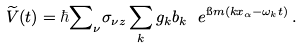<formula> <loc_0><loc_0><loc_500><loc_500>\widetilde { V } ( t ) = \hbar { \sum } _ { \nu } \sigma _ { \nu z } \sum _ { k } g _ { k } b _ { k } \ e ^ { \i m ( k x _ { \alpha } - \omega _ { k } t ) } \, .</formula> 